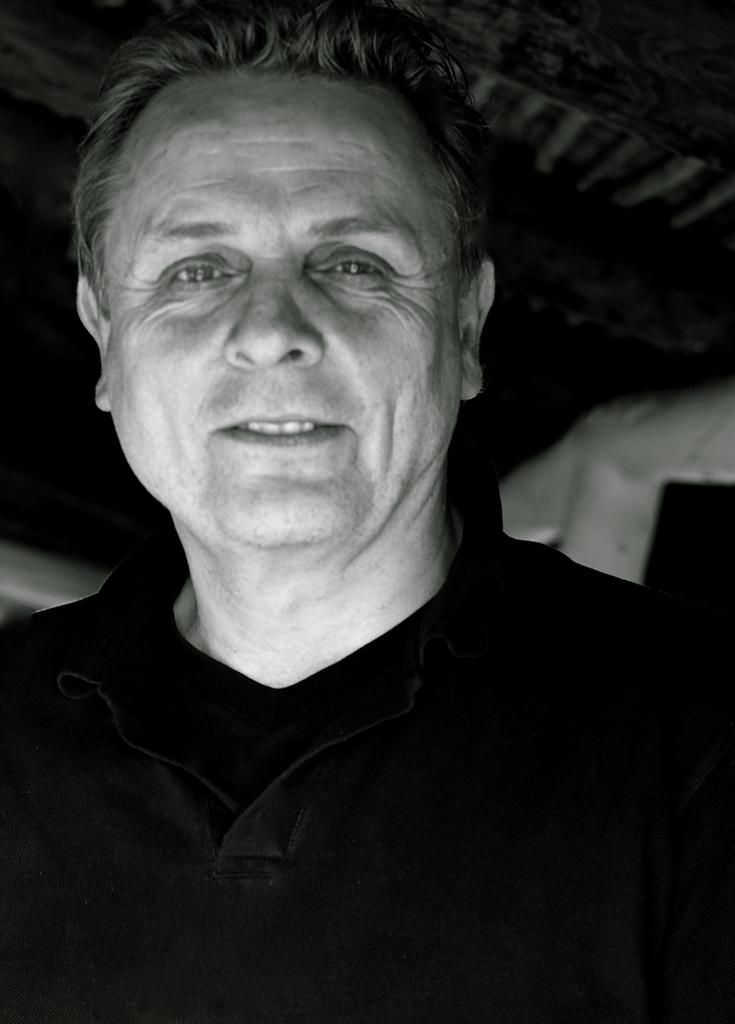What is the color scheme of the image? The image is black and white. Who is present in the image? There is a man in the image. What is the man doing in the image? The man is smiling and posing for the photo. How is the background of the man depicted in the image? The background of the man is blurred. How many cows are visible in the image? There are no cows present in the image. What type of vest is the man wearing in the image? The image is black and white, and there is no indication of the man wearing a vest. 